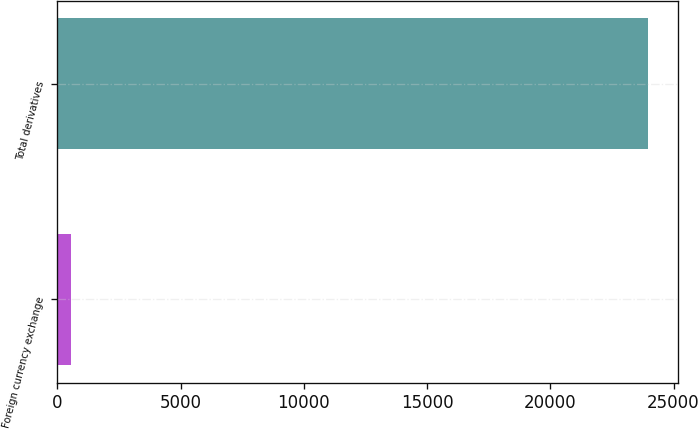Convert chart to OTSL. <chart><loc_0><loc_0><loc_500><loc_500><bar_chart><fcel>Foreign currency exchange<fcel>Total derivatives<nl><fcel>539<fcel>23977.8<nl></chart> 